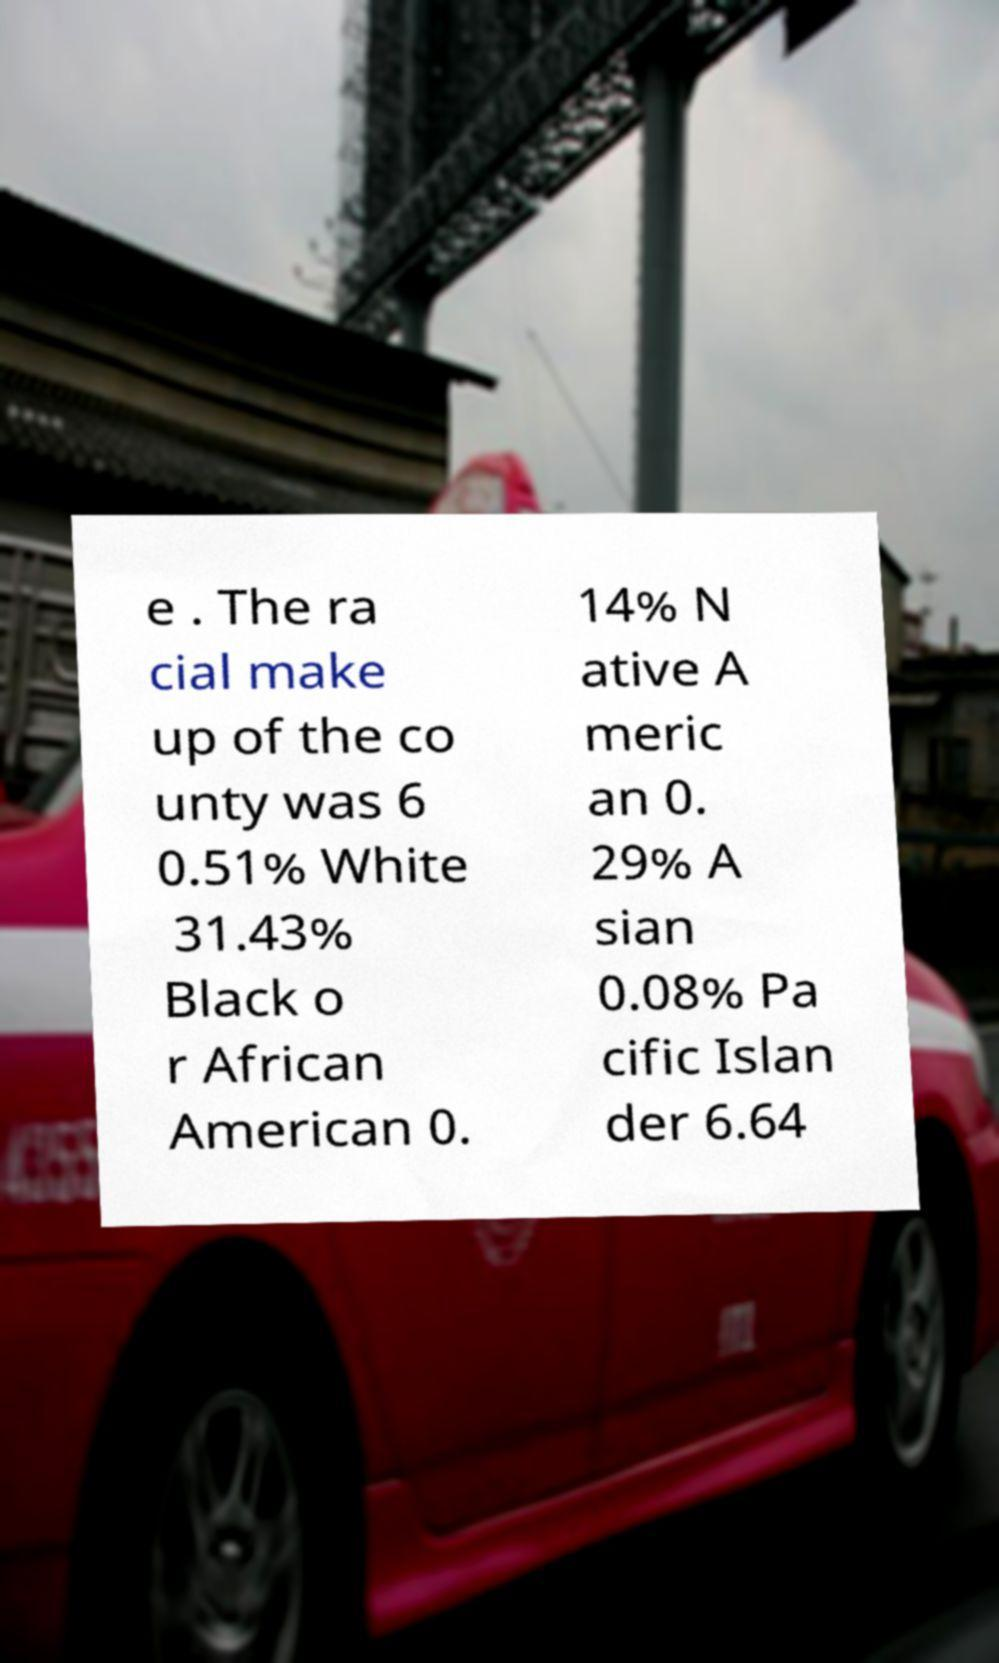What messages or text are displayed in this image? I need them in a readable, typed format. e . The ra cial make up of the co unty was 6 0.51% White 31.43% Black o r African American 0. 14% N ative A meric an 0. 29% A sian 0.08% Pa cific Islan der 6.64 